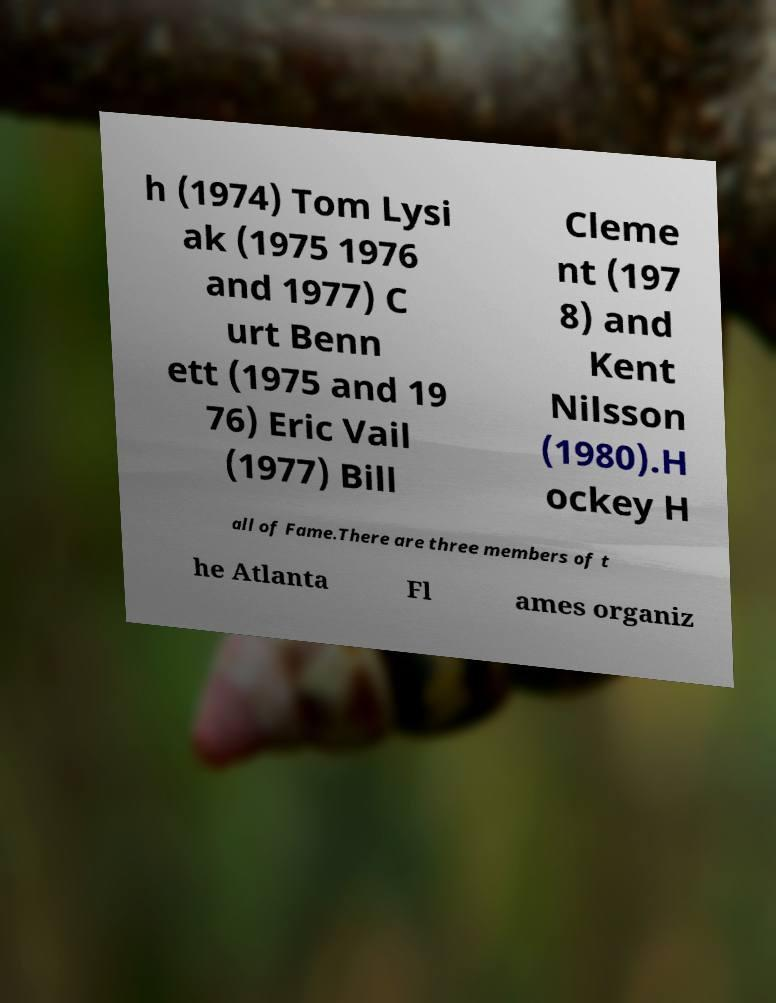Could you assist in decoding the text presented in this image and type it out clearly? h (1974) Tom Lysi ak (1975 1976 and 1977) C urt Benn ett (1975 and 19 76) Eric Vail (1977) Bill Cleme nt (197 8) and Kent Nilsson (1980).H ockey H all of Fame.There are three members of t he Atlanta Fl ames organiz 